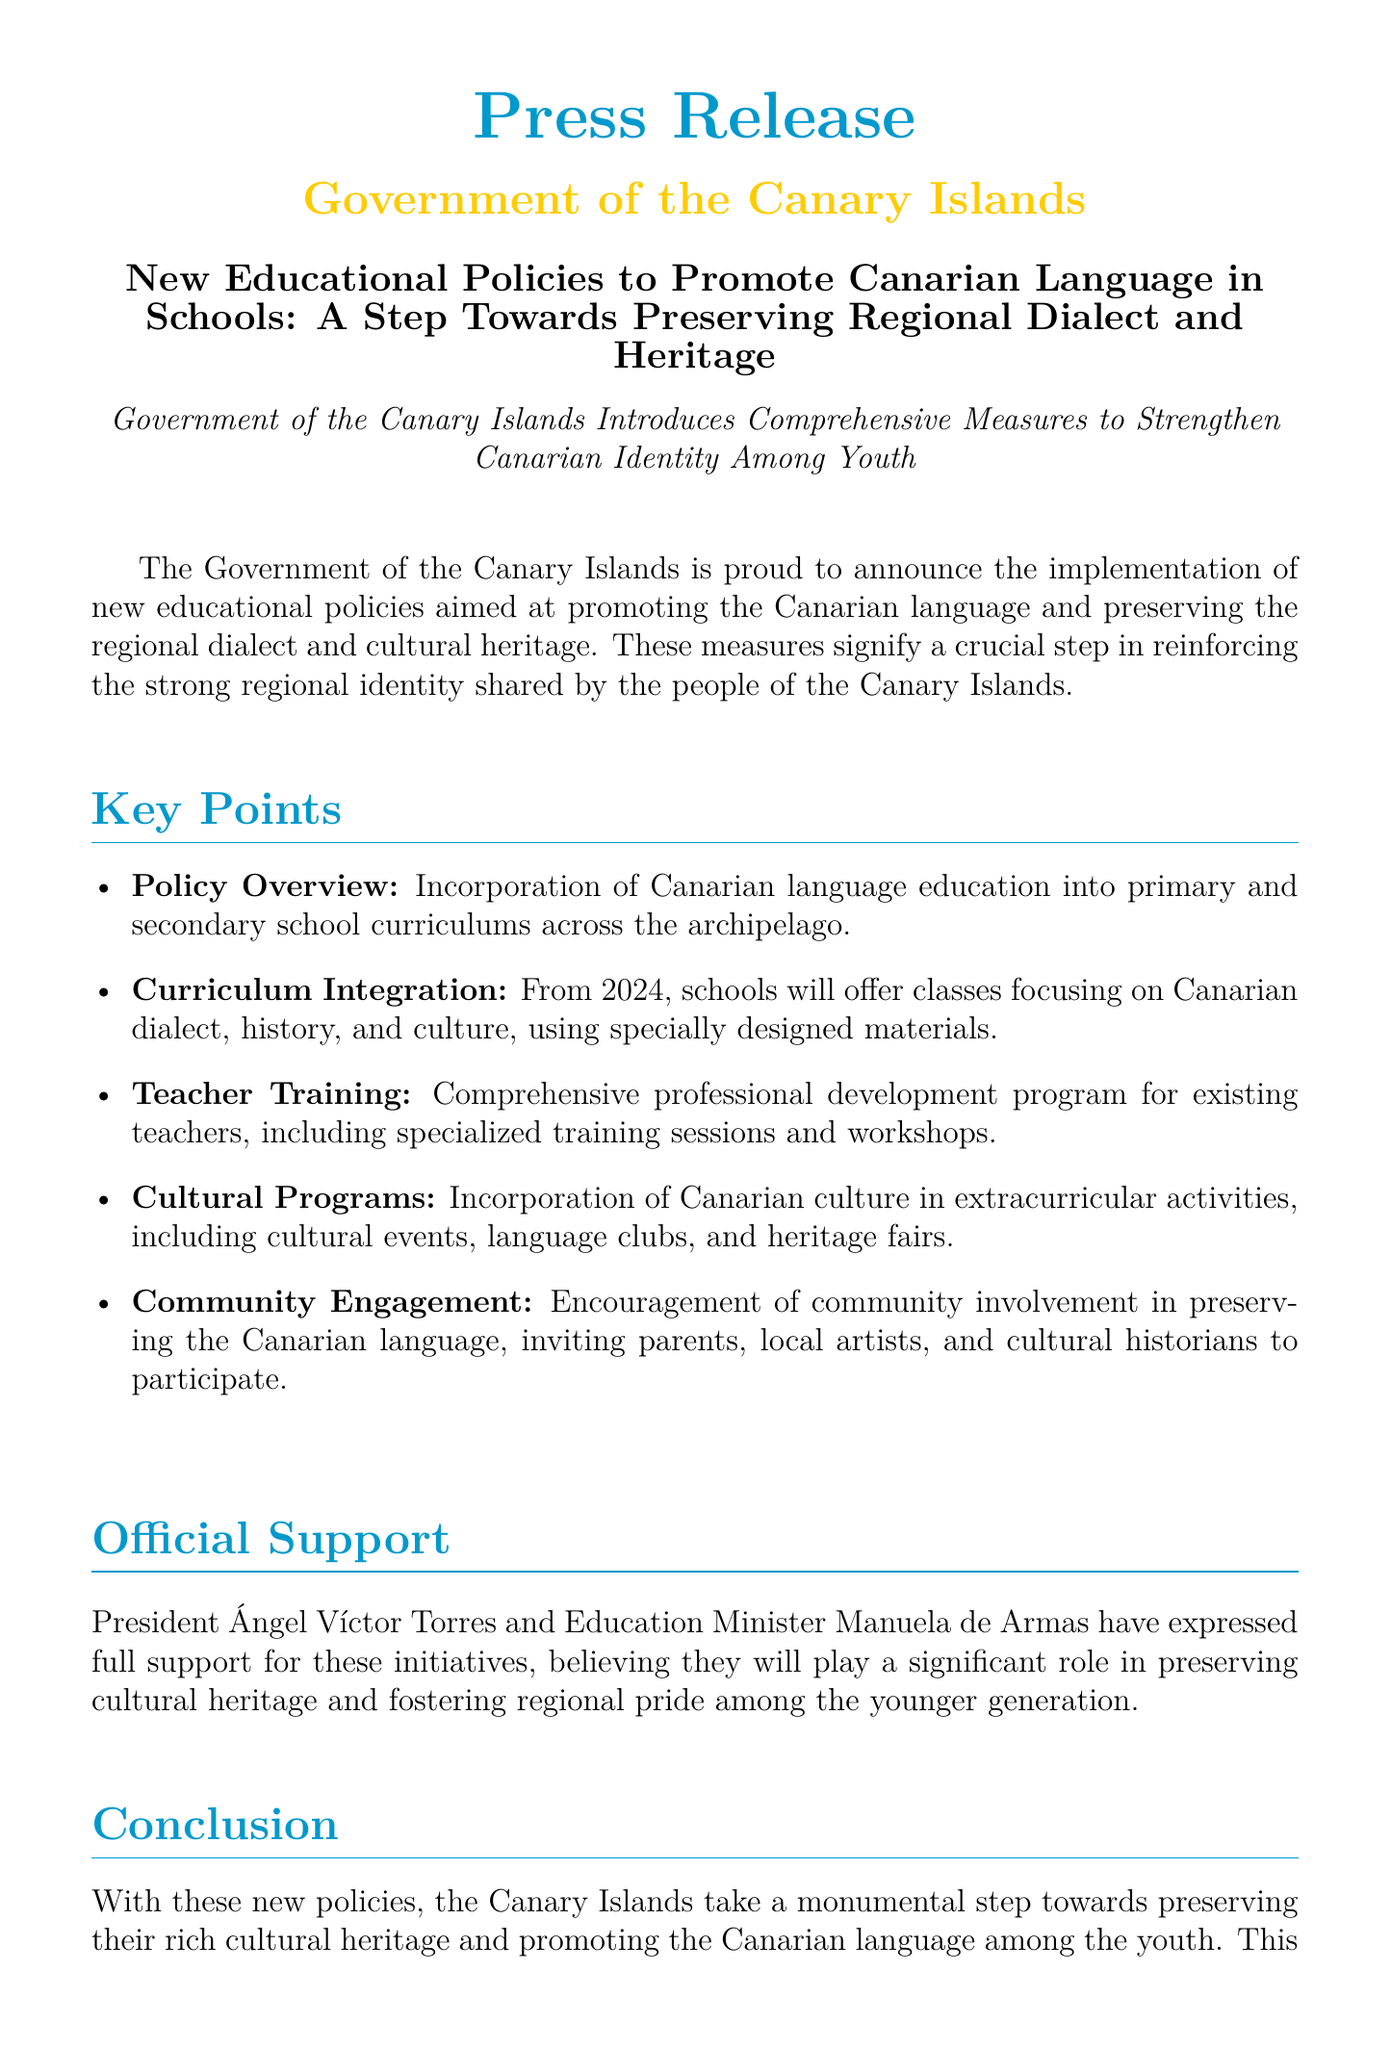What is the title of the press release? The title is a key element that summarizes the main focus of the document, which is about educational policies related to the Canarian language.
Answer: New Educational Policies to Promote Canarian Language in Schools: A Step Towards Preserving Regional Dialect and Heritage Who is the Education Minister referenced in the press release? The Education Minister's name is mentioned as part of the official support section, reflecting government backing for the initiative.
Answer: Manuela de Armas What year will the Canarian language classes be offered in schools? This information is found in the curriculum integration section, indicating the timeline for the implementation of language programs.
Answer: 2024 What are the extracurricular activities mentioned in the document? This refers to the types of programs incorporated into school life beyond formal education, as detailed in the cultural programs section.
Answer: Cultural events, language clubs, and heritage fairs How many key points are listed in the press release? The total number of key points can be counted in the list provided, indicating the main areas of focus in the document.
Answer: Five 